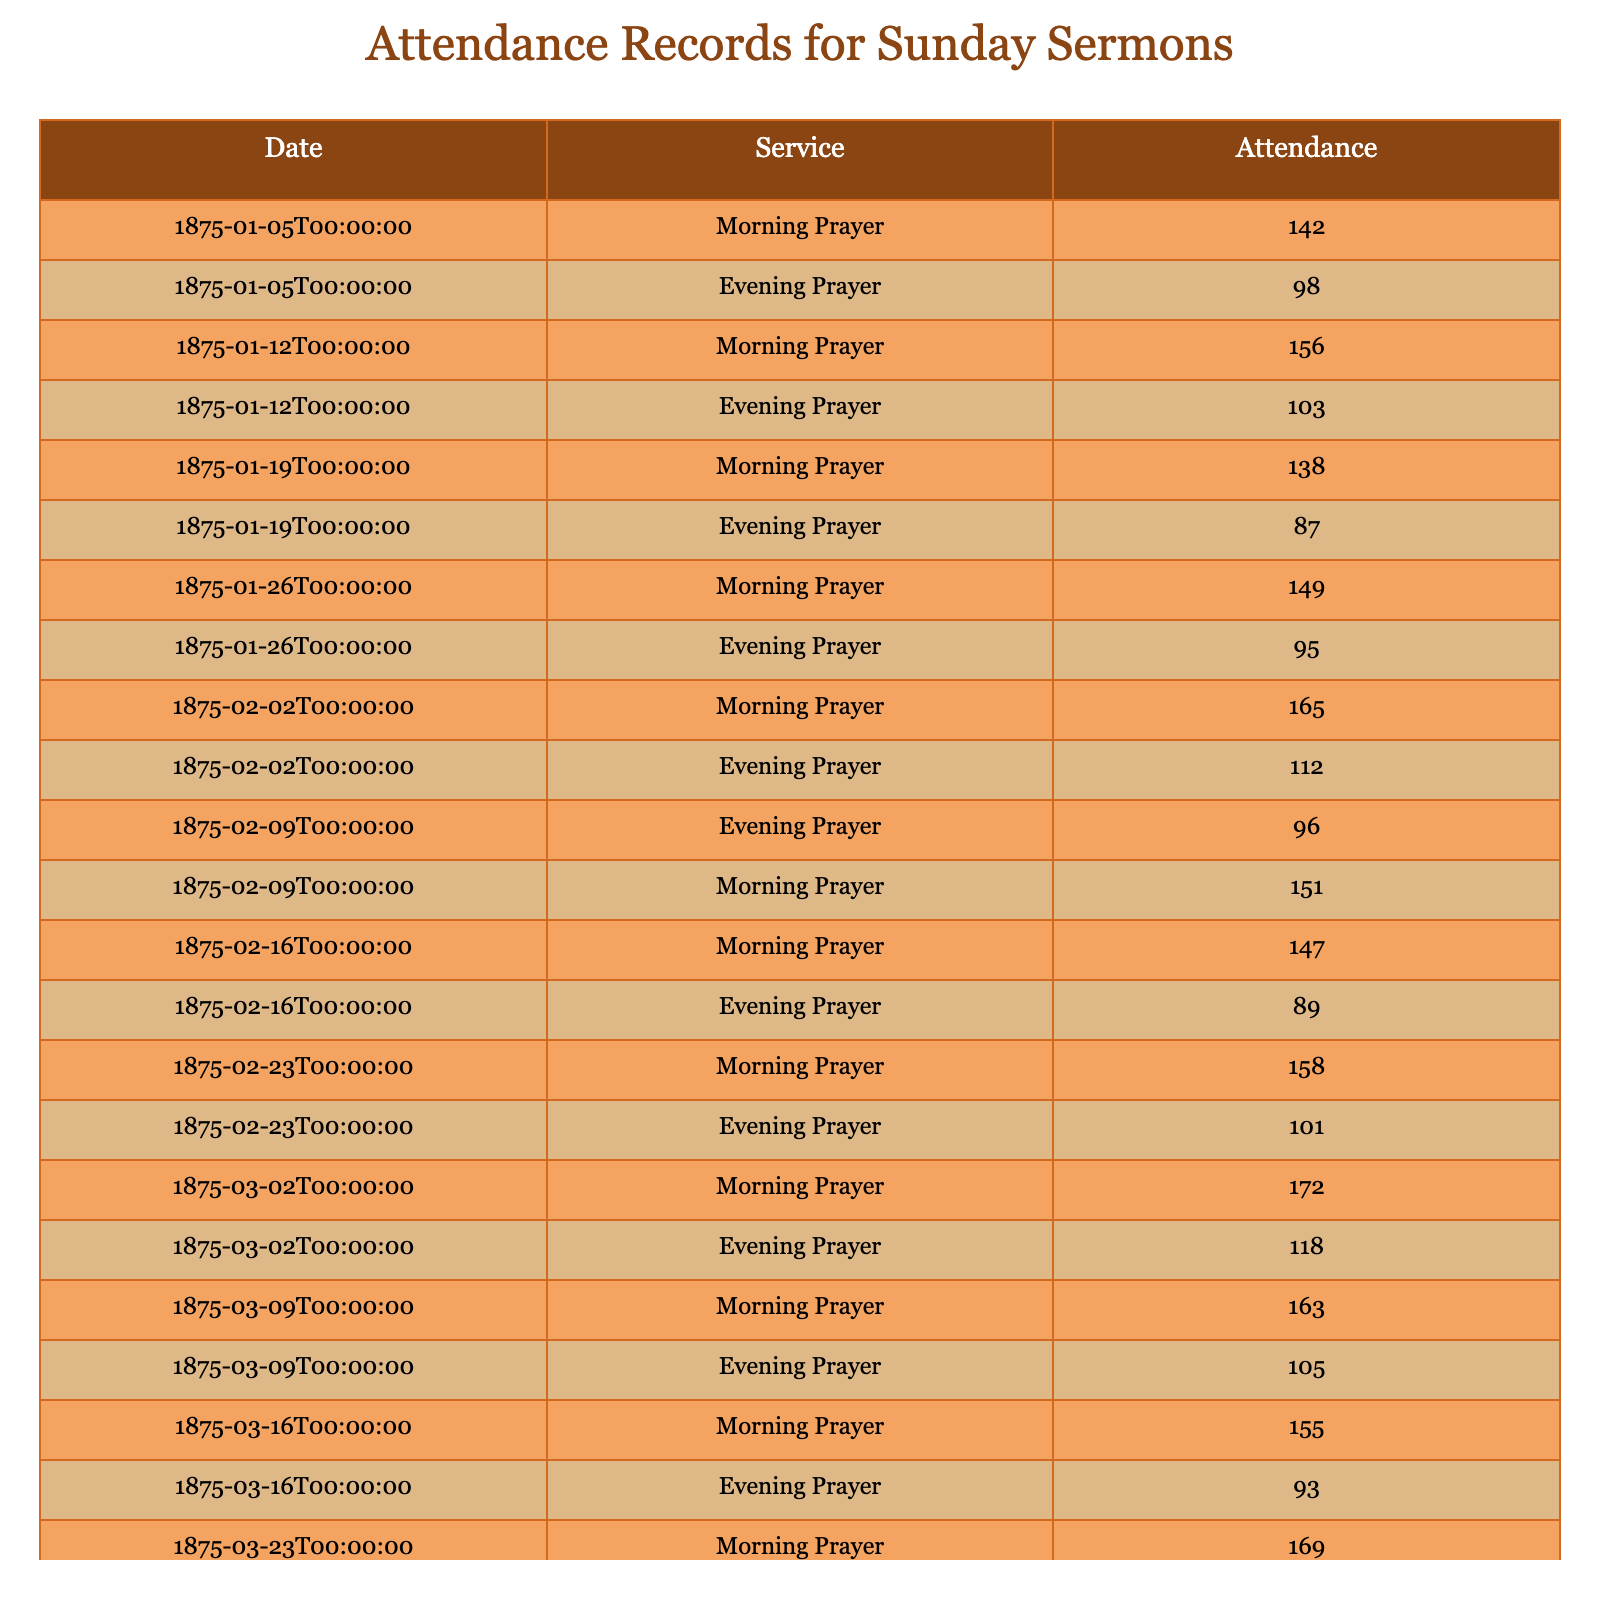What was the attendance for the Evening Prayer on 02/02/1875? The table shows that on the date 02/02/1875, the attendance for the Evening Prayer is listed directly next to the service type. At a glance, we can find that the attendance is 112.
Answer: 112 What was the highest attendance recorded during the Morning Prayer services? By scanning the Morning Prayer rows in the table, the greatest number recorded is 172 on the date 02/03/1875. Hence, this is the highest attendance for the Morning Prayer services.
Answer: 172 Did attendance for Evening Prayer exceed 100 on any occasion? Looking through the Evening Prayer column, we can examine the attendance figures. We see that on several dates such as 02/02/1875 (112) and 02/03/1875 (118), the attendance did indeed exceed 100.
Answer: Yes What was the total attendance for all Morning Prayers over the six months? We sum up all the attendance numbers from the Morning Prayer column: 142 + 156 + 138 + 149 + 165 + 151 + 147 + 158 + 172 + 163 + 155 + 169 = 1,782. Thus, the total attendance is found to be 1,782 across all Morning Prayer services over this period.
Answer: 1782 What was the average attendance for Evening Prayers over the recorded period? First, we take the attendance values for all the Evening Prayer services: 98, 103, 87, 95, 112, 96, 89, 101, 118, 105, 93, and 109. Next, we sum these: 98 + 103 + 87 + 95 + 112 + 96 + 89 + 101 + 118 + 105 + 93 + 109 = 1,197. Then we divide by the number of services (12), giving us an average attendance of 1,197 / 12 = 99.75. Therefore, the average attendance is approximately 100.
Answer: 100 